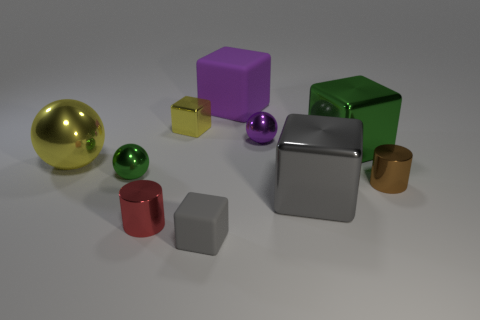There is a brown thing that is the same size as the purple ball; what shape is it? The brown object that matches the size of the purple ball is cylindrical in shape. It's a three-dimensional shape with two identical circular faces connected by a curved surface, which stands out among other geometric forms in the image. 